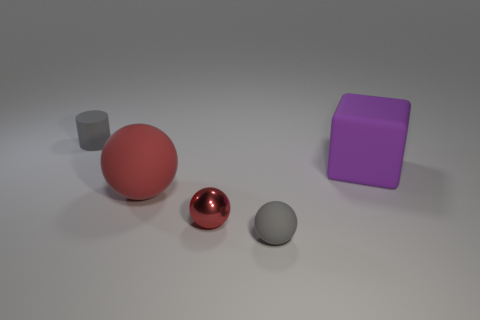Add 1 gray matte cylinders. How many objects exist? 6 Subtract all blocks. How many objects are left? 4 Add 4 large gray cubes. How many large gray cubes exist? 4 Subtract 0 brown balls. How many objects are left? 5 Subtract all small things. Subtract all small red balls. How many objects are left? 1 Add 5 tiny red metallic balls. How many tiny red metallic balls are left? 6 